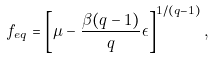Convert formula to latex. <formula><loc_0><loc_0><loc_500><loc_500>f _ { e q } = \left [ \mu - \frac { \beta ( q - 1 ) } { q } \epsilon \right ] ^ { 1 / ( q - 1 ) } ,</formula> 